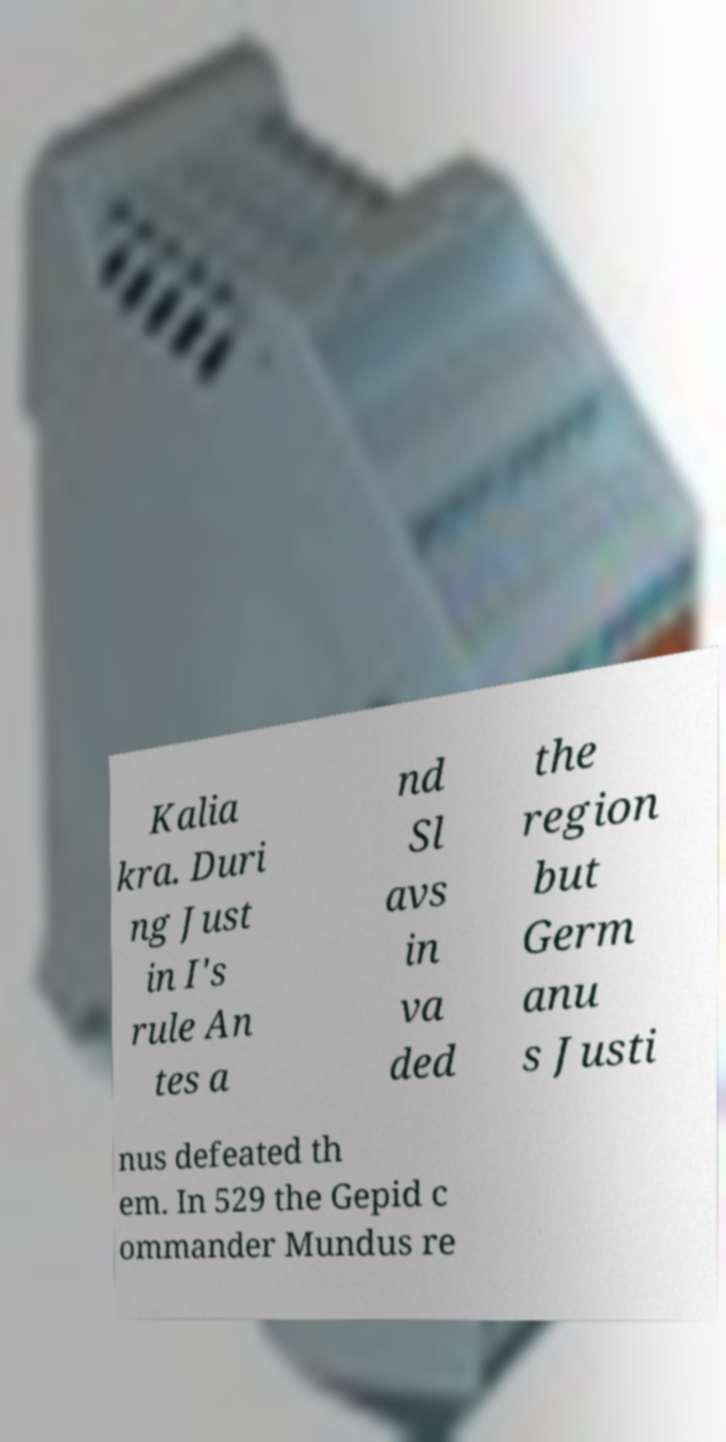Can you read and provide the text displayed in the image?This photo seems to have some interesting text. Can you extract and type it out for me? Kalia kra. Duri ng Just in I's rule An tes a nd Sl avs in va ded the region but Germ anu s Justi nus defeated th em. In 529 the Gepid c ommander Mundus re 